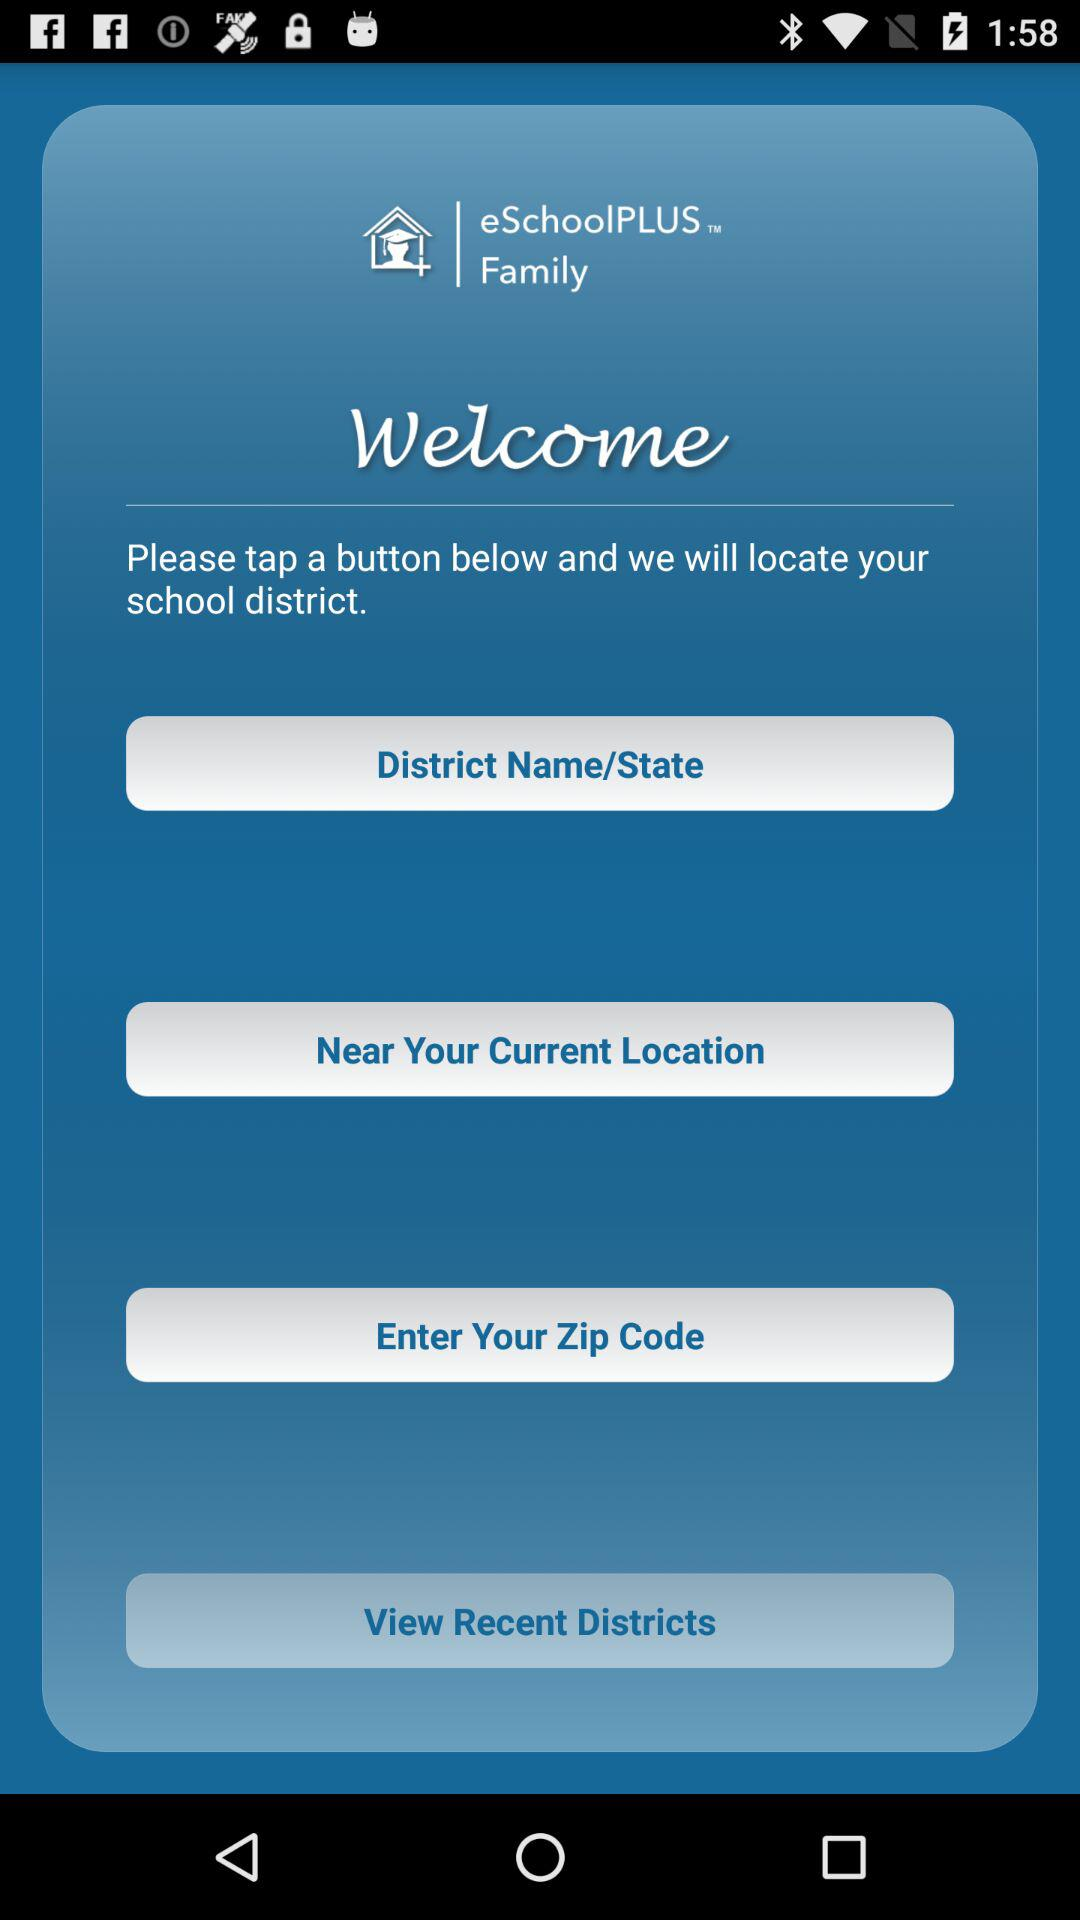What is the name of the application? The name of the application is "eSchoolPLUS Family". 